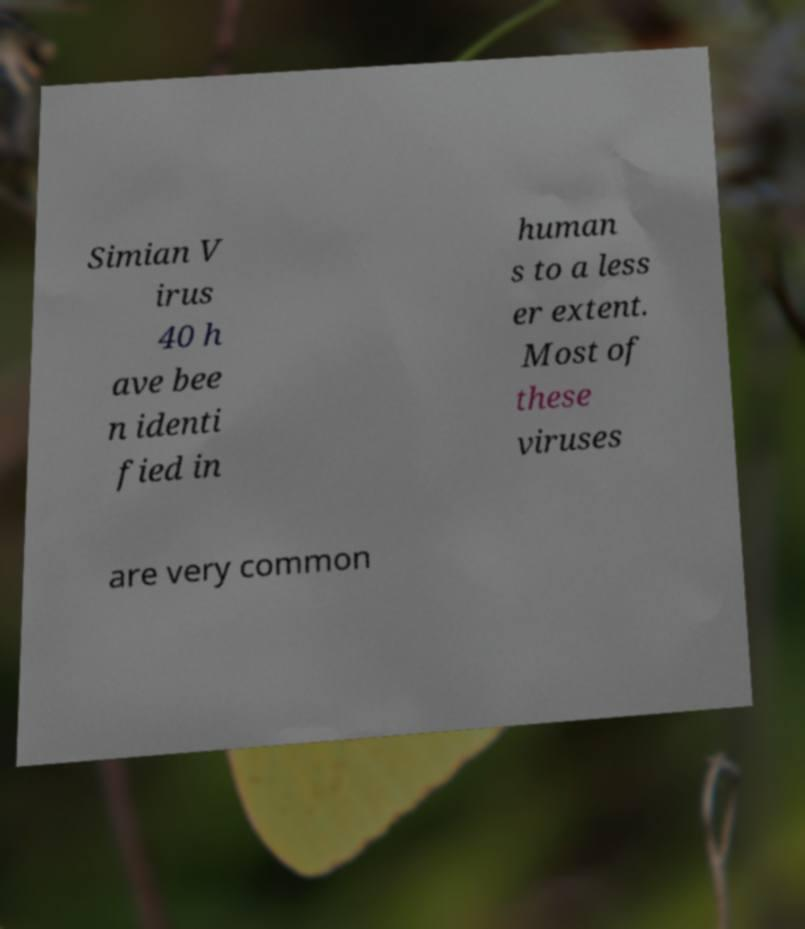What messages or text are displayed in this image? I need them in a readable, typed format. Simian V irus 40 h ave bee n identi fied in human s to a less er extent. Most of these viruses are very common 